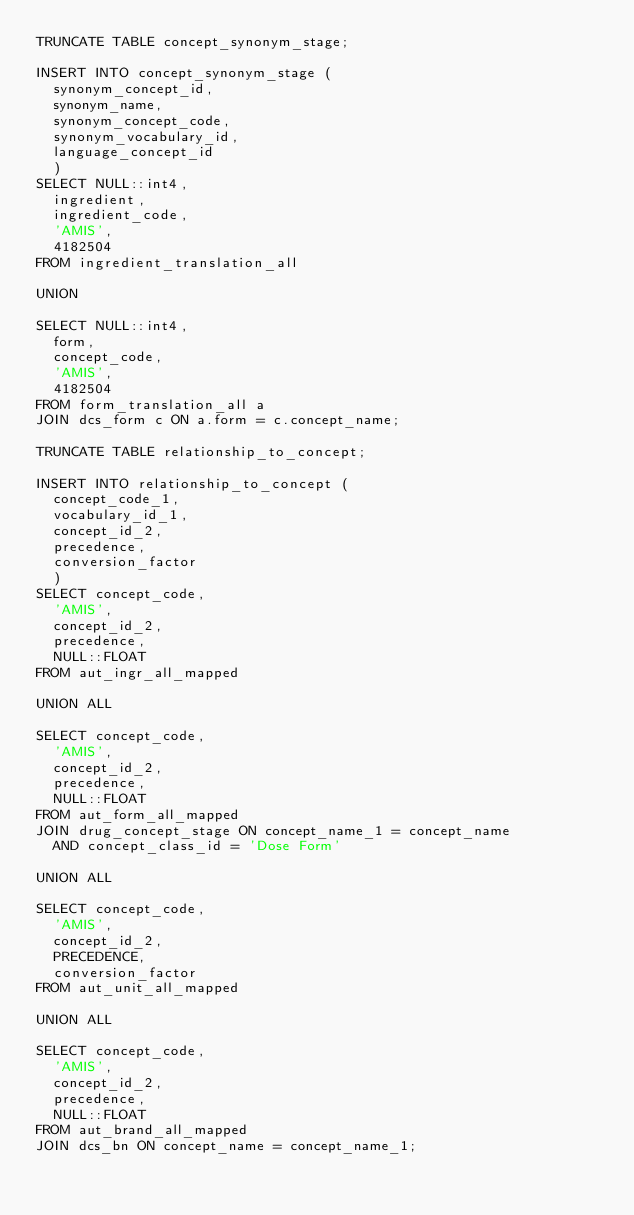<code> <loc_0><loc_0><loc_500><loc_500><_SQL_>TRUNCATE TABLE concept_synonym_stage;

INSERT INTO concept_synonym_stage (
	synonym_concept_id,
	synonym_name,
	synonym_concept_code,
	synonym_vocabulary_id,
	language_concept_id
	)
SELECT NULL::int4,
	ingredient,
	ingredient_code,
	'AMIS',
	4182504
FROM ingredient_translation_all

UNION

SELECT NULL::int4,
	form,
	concept_code,
	'AMIS',
	4182504
FROM form_translation_all a
JOIN dcs_form c ON a.form = c.concept_name;

TRUNCATE TABLE relationship_to_concept;

INSERT INTO relationship_to_concept (
	concept_code_1,
	vocabulary_id_1,
	concept_id_2,
	precedence,
	conversion_factor
	)
SELECT concept_code,
	'AMIS',
	concept_id_2,
	precedence,
	NULL::FLOAT
FROM aut_ingr_all_mapped

UNION ALL

SELECT concept_code,
	'AMIS',
	concept_id_2,
	precedence,
	NULL::FLOAT
FROM aut_form_all_mapped
JOIN drug_concept_stage ON concept_name_1 = concept_name
	AND concept_class_id = 'Dose Form'

UNION ALL

SELECT concept_code,
	'AMIS',
	concept_id_2,
	PRECEDENCE,
	conversion_factor
FROM aut_unit_all_mapped

UNION ALL

SELECT concept_code,
	'AMIS',
	concept_id_2,
	precedence,
	NULL::FLOAT
FROM aut_brand_all_mapped
JOIN dcs_bn ON concept_name = concept_name_1;

</code> 